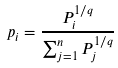Convert formula to latex. <formula><loc_0><loc_0><loc_500><loc_500>p _ { i } = \frac { P _ { i } ^ { 1 / q } } { \sum _ { j = 1 } ^ { n } P _ { j } ^ { 1 / q } }</formula> 